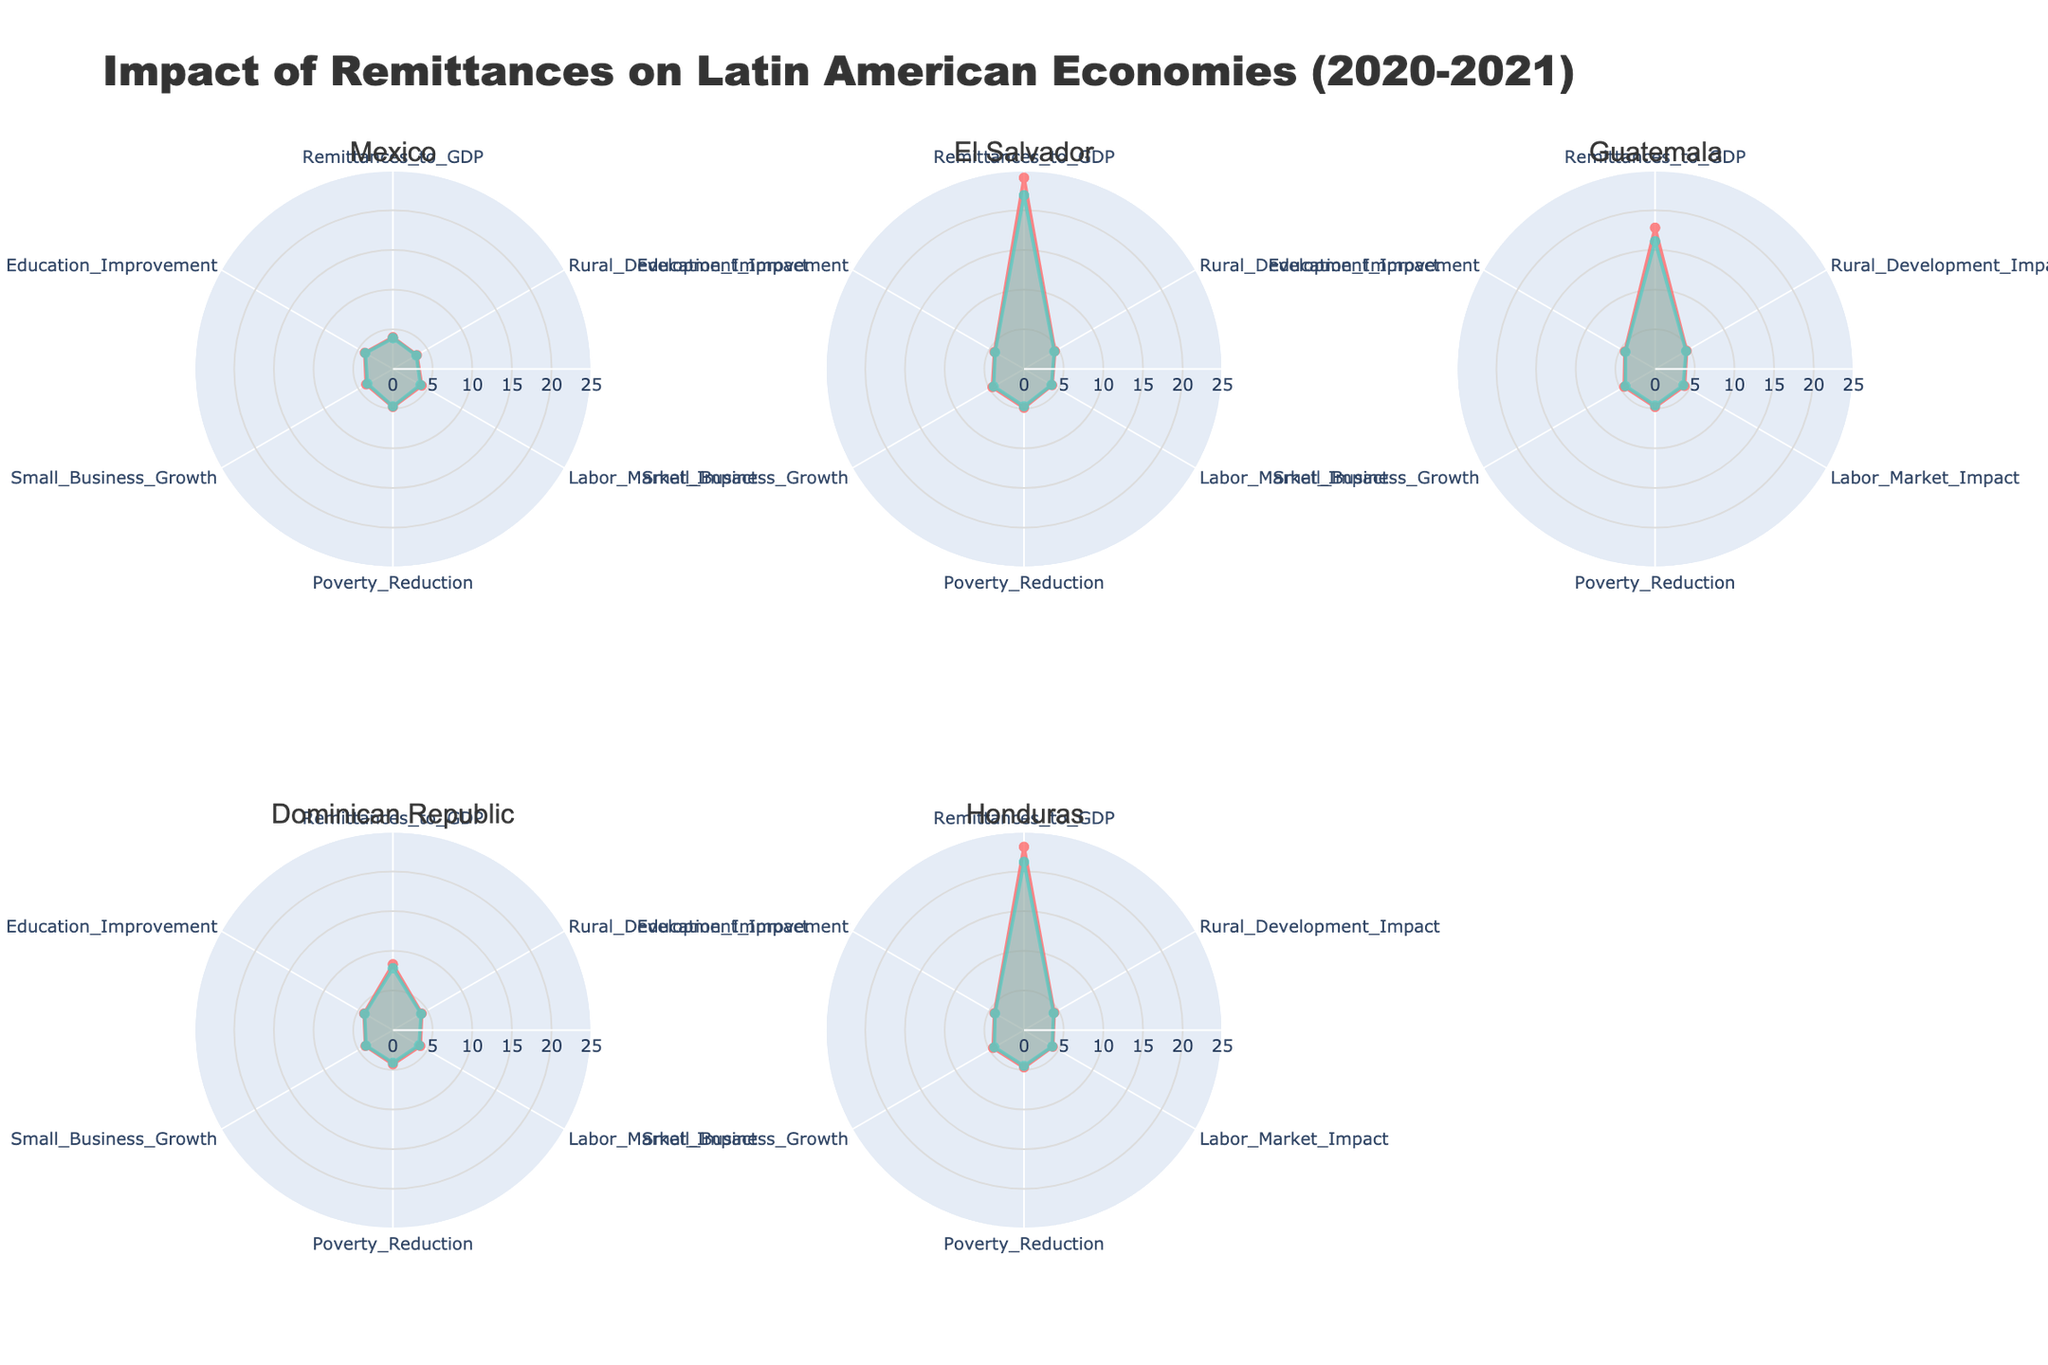What is the title of the figure? The title is displayed at the top center of the figure.
Answer: Impact of Remittances on Latin American Economies (2020-2021) How many countries are analyzed in the figure? Each subplot represents a country, and the subplots are arranged in a grid with titles showing country names. Count the titles.
Answer: 5 Which country has the highest remittances to GDP ratio in 2021? Look for the high endpoint of the "Remittances_to_GDP" axis in the corresponding subplot for 2021.
Answer: El Salvador Did Mexico have an increase or decrease in its remittances to GDP ratio from 2020 to 2021? Check Mexico's subplot and compare the values of "Remittances_to_GDP" for 2020 and 2021.
Answer: Increase Which country shows the highest impact on Poverty Reduction in 2021? Identify the values on the "Poverty_Reduction" axis for each country in 2021 and find the highest.
Answer: El Salvador Compare the impact on Rural Development between Guatemala and Honduras in 2021. Which country had a higher impact? Look at the "Rural_Development_Impact" axis for 2021 in Guatemala and Honduras' subplots and compare.
Answer: Guatemala For which country do the impact values on Labor Market in 2020 and 2021 remain consistent? Check the "Labor_Market_Impact" axis for 2020 and 2021 in each subplot to find the consistent values.
Answer: El Salvador What is the average impact on Education Improvement for the Dominican Republic across 2020 and 2021? Add the values of "Education_Improvement" for 2020 and 2021 for the Dominican Republic and divide by 2.
Answer: 4.15 Between Honduras and El Salvador, which country experienced a greater increase in Small Business Growth from 2020 to 2021? Calculate the difference in "Small_Business_Growth" for both countries between the two years and compare.
Answer: El Salvador How does the impact on Rural Development in Guatemala in 2021 compare with that of Mexico in the same year? Compare the values of "Rural_Development_Impact" in 2021 between Guatemala and Mexico to see which is higher.
Answer: Guatemala 